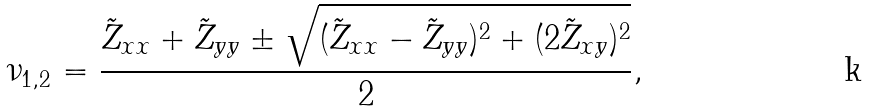Convert formula to latex. <formula><loc_0><loc_0><loc_500><loc_500>\nu _ { 1 , 2 } = \frac { \tilde { Z } _ { x x } + \tilde { Z } _ { y y } \pm \sqrt { ( \tilde { Z } _ { x x } - \tilde { Z } _ { y y } ) ^ { 2 } + ( 2 \tilde { Z } _ { x y } ) ^ { 2 } } } { 2 } ,</formula> 